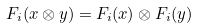Convert formula to latex. <formula><loc_0><loc_0><loc_500><loc_500>F _ { i } ( x \otimes y ) = F _ { i } ( x ) \otimes F _ { i } ( y )</formula> 